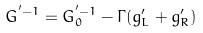<formula> <loc_0><loc_0><loc_500><loc_500>G ^ { ^ { \prime } - 1 } = G _ { 0 } ^ { ^ { \prime } - 1 } - \Gamma ( g ^ { \prime } _ { L } + g ^ { \prime } _ { R } )</formula> 